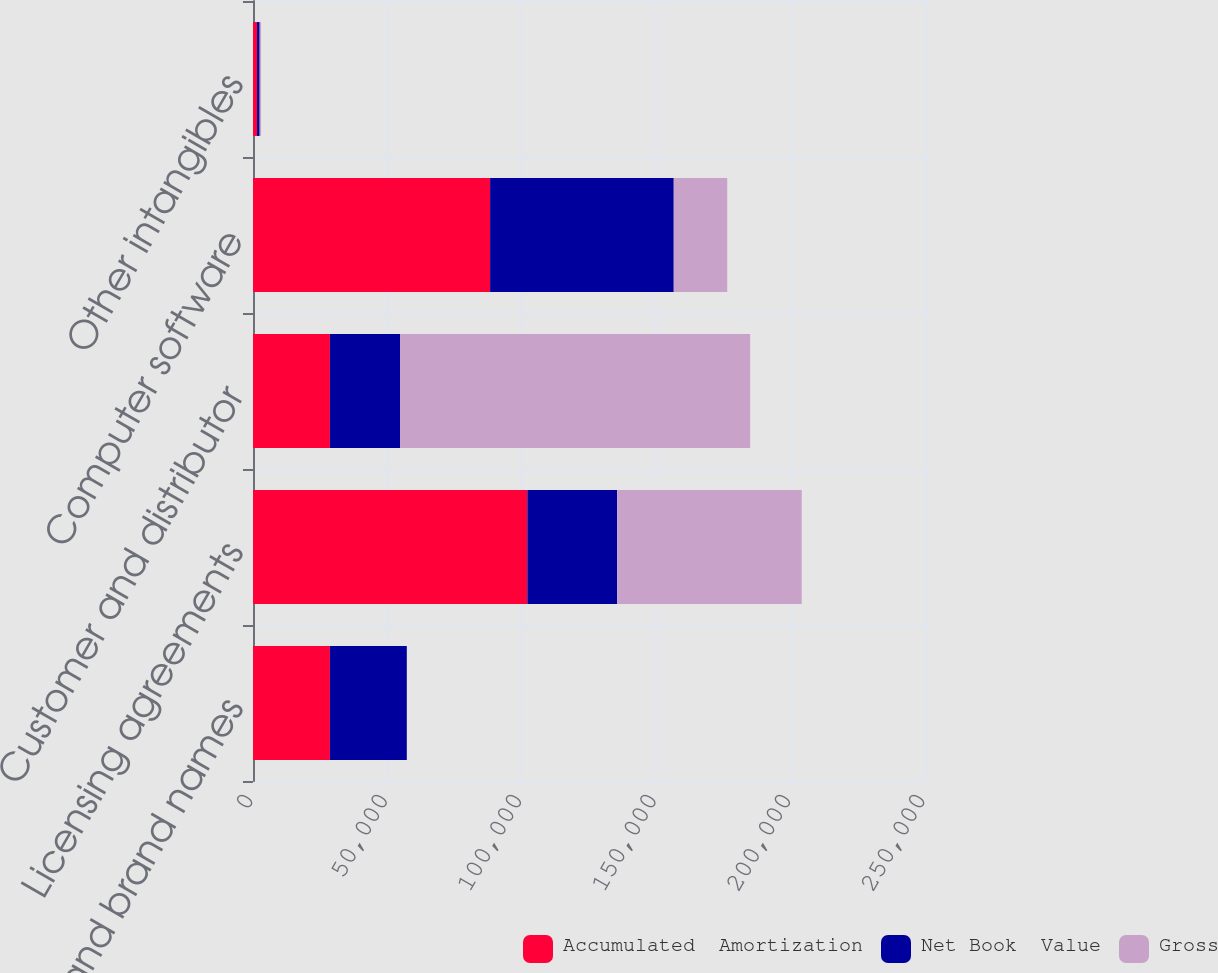<chart> <loc_0><loc_0><loc_500><loc_500><stacked_bar_chart><ecel><fcel>Trademarks and brand names<fcel>Licensing agreements<fcel>Customer and distributor<fcel>Computer software<fcel>Other intangibles<nl><fcel>Accumulated  Amortization<fcel>28617<fcel>102069<fcel>28612<fcel>88213<fcel>1498<nl><fcel>Net Book  Value<fcel>28607<fcel>33397<fcel>26153<fcel>68318<fcel>994<nl><fcel>Gross<fcel>10<fcel>68672<fcel>130187<fcel>19895<fcel>504<nl></chart> 